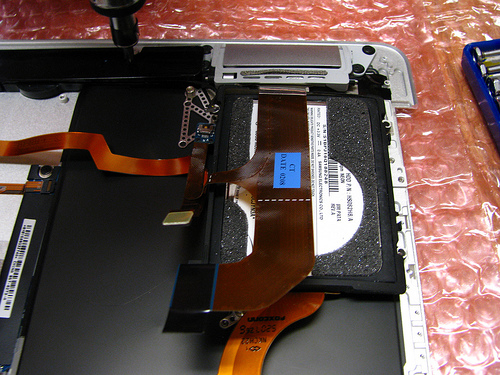<image>
Is the computer on the bubble wrap? Yes. Looking at the image, I can see the computer is positioned on top of the bubble wrap, with the bubble wrap providing support. 